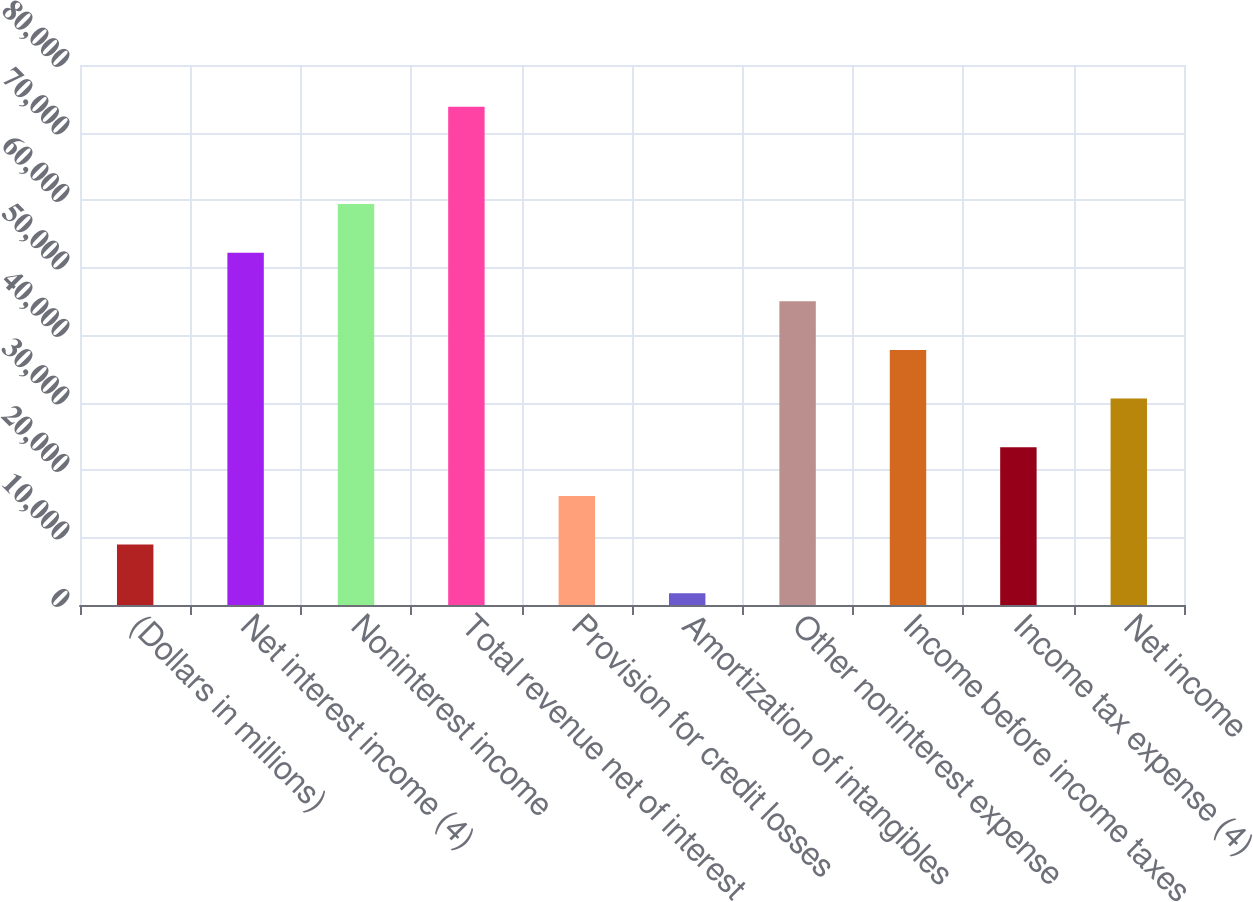Convert chart. <chart><loc_0><loc_0><loc_500><loc_500><bar_chart><fcel>(Dollars in millions)<fcel>Net interest income (4)<fcel>Noninterest income<fcel>Total revenue net of interest<fcel>Provision for credit losses<fcel>Amortization of intangibles<fcel>Other noninterest expense<fcel>Income before income taxes<fcel>Income tax expense (4)<fcel>Net income<nl><fcel>8959.9<fcel>52189.3<fcel>59394.2<fcel>73804<fcel>16164.8<fcel>1755<fcel>44984.4<fcel>37779.5<fcel>23369.7<fcel>30574.6<nl></chart> 